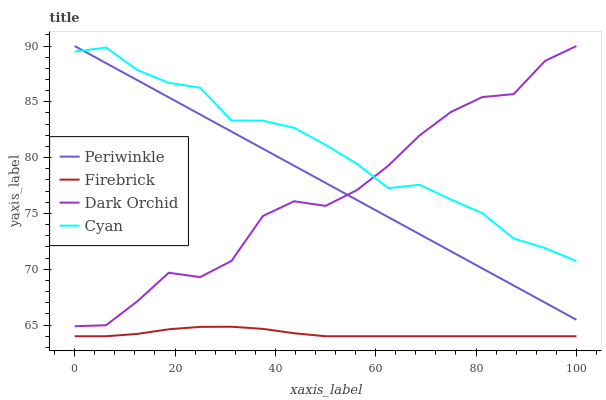Does Firebrick have the minimum area under the curve?
Answer yes or no. Yes. Does Cyan have the maximum area under the curve?
Answer yes or no. Yes. Does Periwinkle have the minimum area under the curve?
Answer yes or no. No. Does Periwinkle have the maximum area under the curve?
Answer yes or no. No. Is Periwinkle the smoothest?
Answer yes or no. Yes. Is Dark Orchid the roughest?
Answer yes or no. Yes. Is Firebrick the smoothest?
Answer yes or no. No. Is Firebrick the roughest?
Answer yes or no. No. Does Firebrick have the lowest value?
Answer yes or no. Yes. Does Periwinkle have the lowest value?
Answer yes or no. No. Does Dark Orchid have the highest value?
Answer yes or no. Yes. Does Firebrick have the highest value?
Answer yes or no. No. Is Firebrick less than Dark Orchid?
Answer yes or no. Yes. Is Periwinkle greater than Firebrick?
Answer yes or no. Yes. Does Periwinkle intersect Cyan?
Answer yes or no. Yes. Is Periwinkle less than Cyan?
Answer yes or no. No. Is Periwinkle greater than Cyan?
Answer yes or no. No. Does Firebrick intersect Dark Orchid?
Answer yes or no. No. 